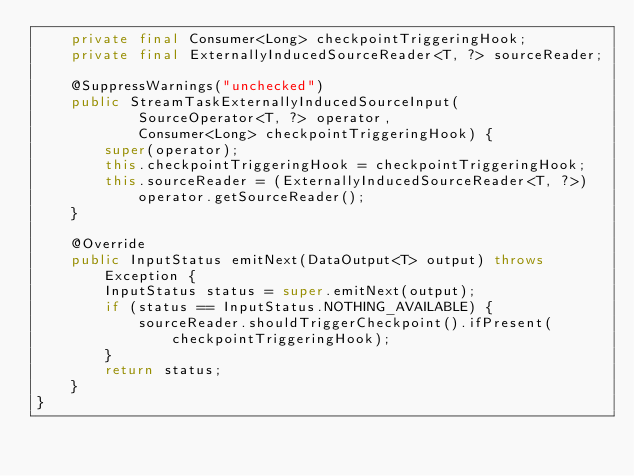<code> <loc_0><loc_0><loc_500><loc_500><_Java_>	private final Consumer<Long> checkpointTriggeringHook;
	private final ExternallyInducedSourceReader<T, ?> sourceReader;

	@SuppressWarnings("unchecked")
	public StreamTaskExternallyInducedSourceInput(
			SourceOperator<T, ?> operator,
			Consumer<Long> checkpointTriggeringHook) {
		super(operator);
		this.checkpointTriggeringHook = checkpointTriggeringHook;
		this.sourceReader = (ExternallyInducedSourceReader<T, ?>) operator.getSourceReader();
	}

	@Override
	public InputStatus emitNext(DataOutput<T> output) throws Exception {
		InputStatus status = super.emitNext(output);
		if (status == InputStatus.NOTHING_AVAILABLE) {
			sourceReader.shouldTriggerCheckpoint().ifPresent(checkpointTriggeringHook);
		}
		return status;
	}
}
</code> 